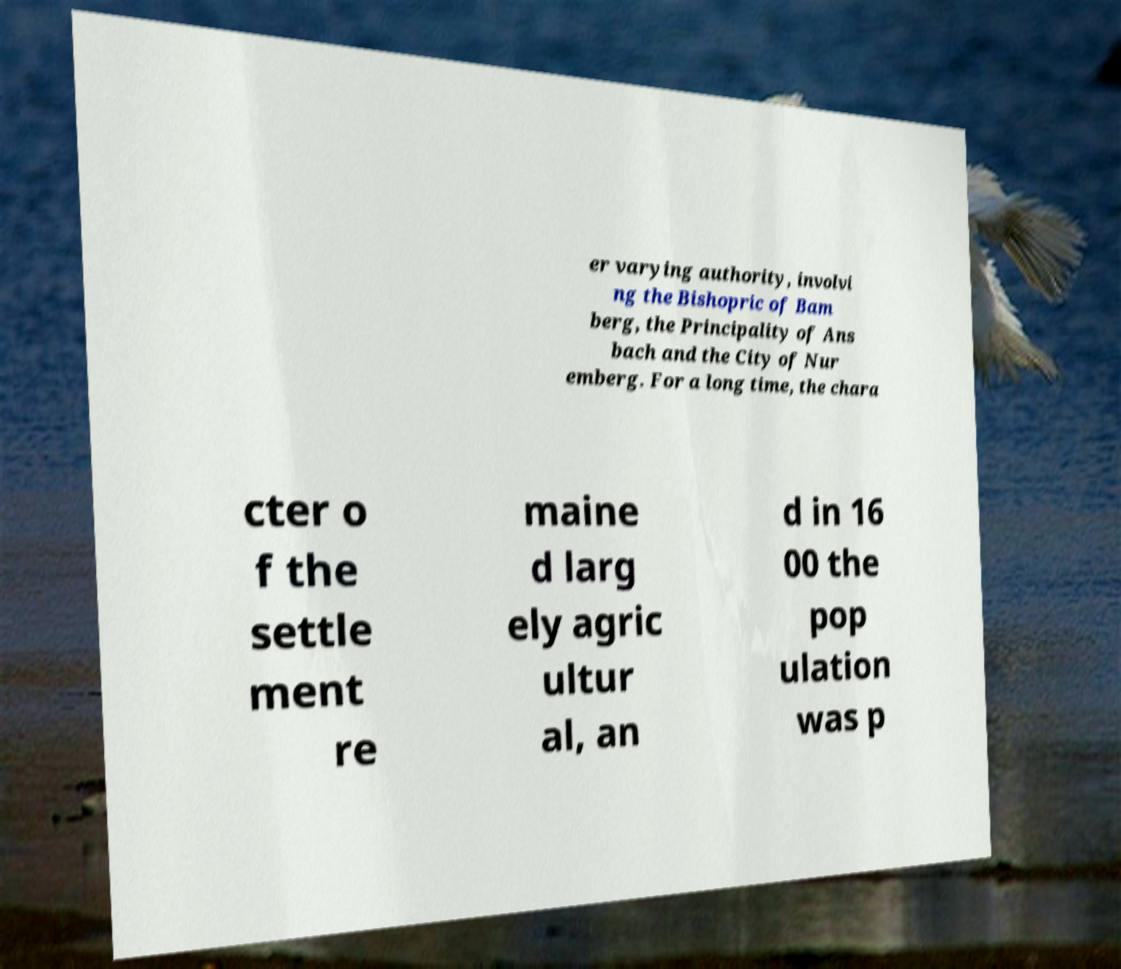Can you accurately transcribe the text from the provided image for me? er varying authority, involvi ng the Bishopric of Bam berg, the Principality of Ans bach and the City of Nur emberg. For a long time, the chara cter o f the settle ment re maine d larg ely agric ultur al, an d in 16 00 the pop ulation was p 